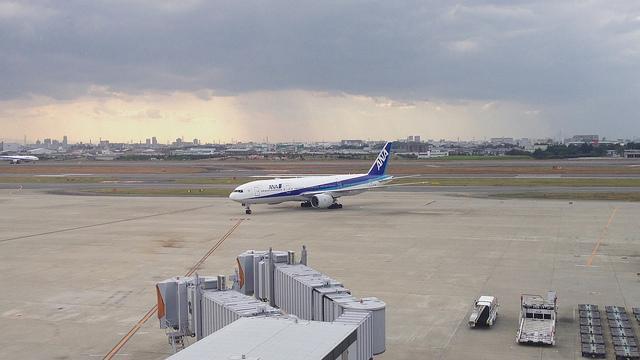How many planes on the runway?
Give a very brief answer. 1. How many giraffes are there?
Give a very brief answer. 0. 